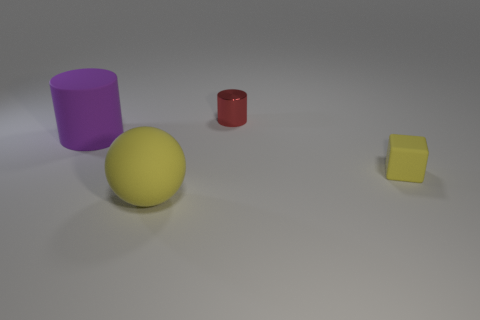Is there any other thing that has the same material as the red cylinder?
Keep it short and to the point. No. There is a matte object that is the same shape as the red metal thing; what size is it?
Give a very brief answer. Large. What size is the matte sphere that is the same color as the small matte thing?
Provide a succinct answer. Large. There is a big object that is right of the big cylinder; does it have the same shape as the small rubber object?
Provide a succinct answer. No. There is a red cylinder that is to the right of the matte sphere; what material is it?
Offer a terse response. Metal. There is a small matte thing that is the same color as the big sphere; what is its shape?
Your answer should be very brief. Cube. Is there a purple thing that has the same material as the cube?
Ensure brevity in your answer.  Yes. What is the size of the purple cylinder?
Provide a short and direct response. Large. What number of red things are either balls or small objects?
Ensure brevity in your answer.  1. What number of other small red things have the same shape as the tiny metallic thing?
Offer a very short reply. 0. 